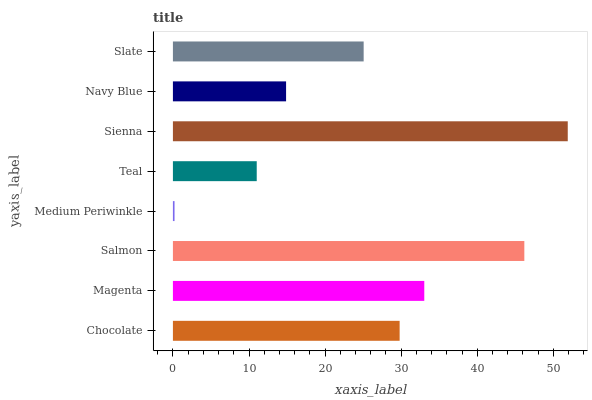Is Medium Periwinkle the minimum?
Answer yes or no. Yes. Is Sienna the maximum?
Answer yes or no. Yes. Is Magenta the minimum?
Answer yes or no. No. Is Magenta the maximum?
Answer yes or no. No. Is Magenta greater than Chocolate?
Answer yes or no. Yes. Is Chocolate less than Magenta?
Answer yes or no. Yes. Is Chocolate greater than Magenta?
Answer yes or no. No. Is Magenta less than Chocolate?
Answer yes or no. No. Is Chocolate the high median?
Answer yes or no. Yes. Is Slate the low median?
Answer yes or no. Yes. Is Magenta the high median?
Answer yes or no. No. Is Magenta the low median?
Answer yes or no. No. 